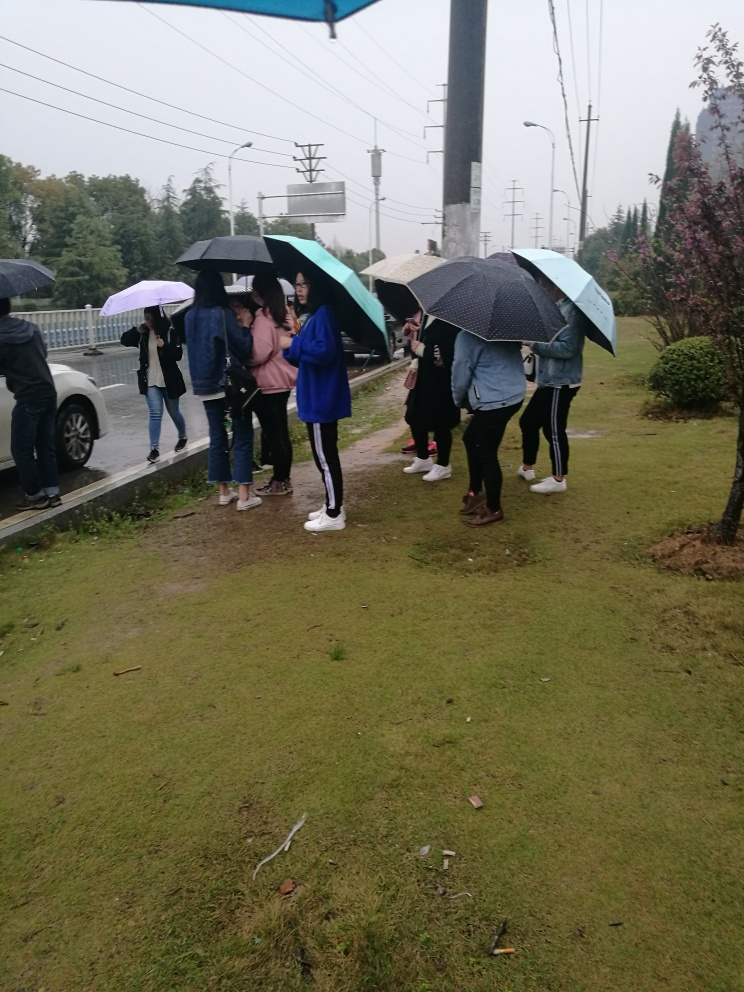Can you comment on the attire and preparedness of the people? Most individuals are dressed in light outerwear suitable for mild temperatures, and the use of umbrellas shows a level of preparedness for rainy weather. Considering the conditions, what might be a good recommendation for someone about to join this scene? A good recommendation would be to wear waterproof footwear, a waterproof jacket, or a coat for protection against the rain, and to carry an umbrella for added comfort. 